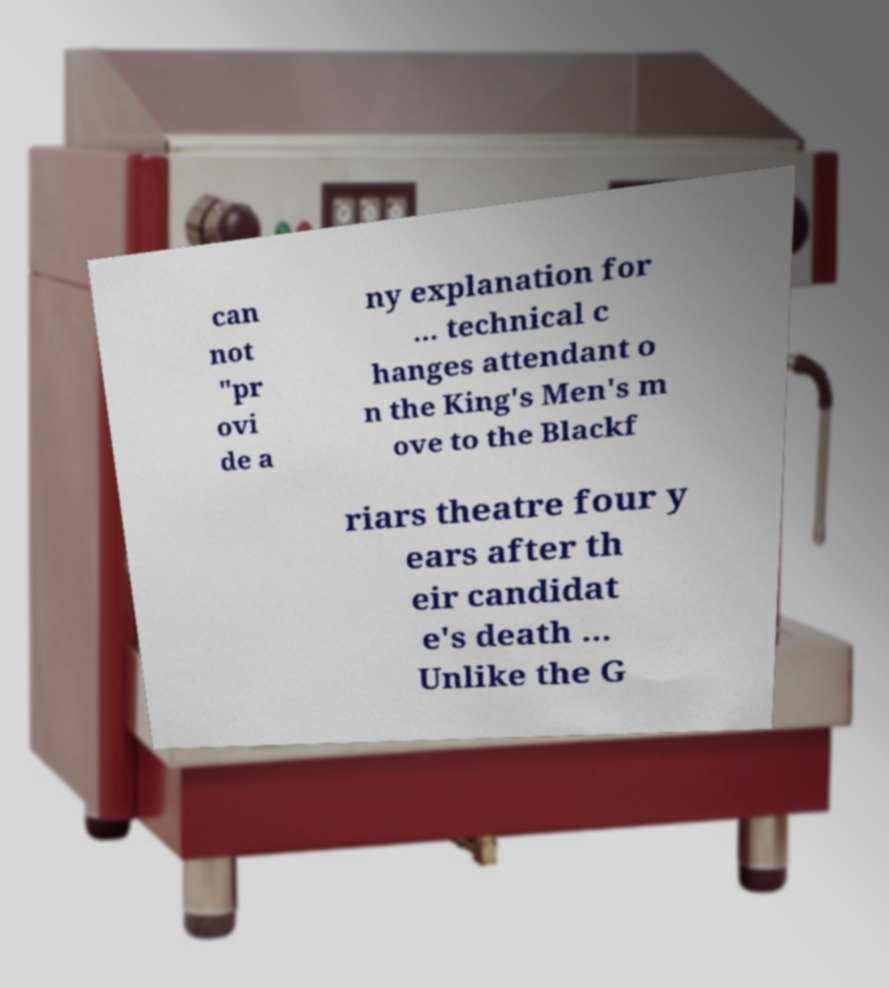Could you assist in decoding the text presented in this image and type it out clearly? can not "pr ovi de a ny explanation for ... technical c hanges attendant o n the King's Men's m ove to the Blackf riars theatre four y ears after th eir candidat e's death ... Unlike the G 